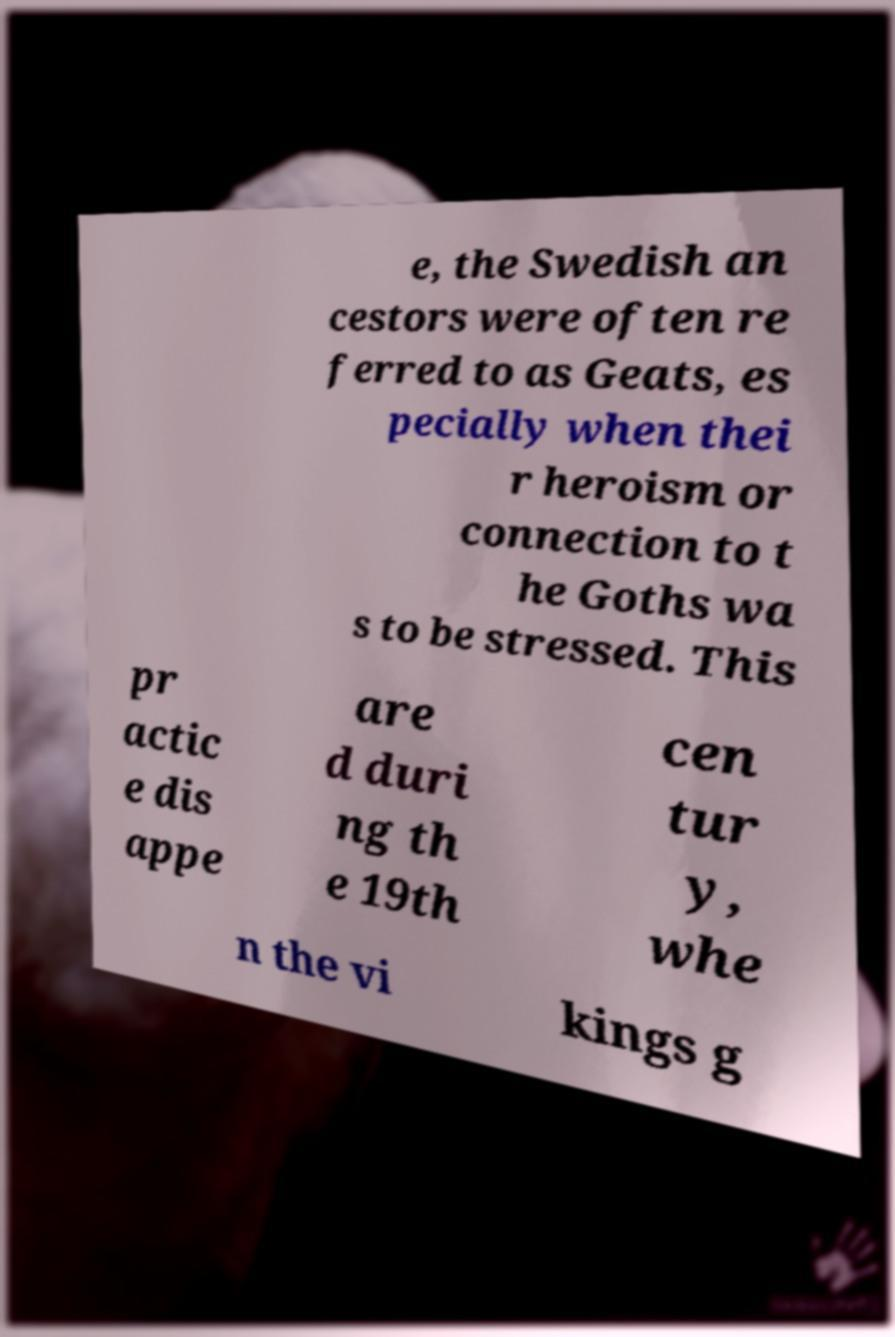I need the written content from this picture converted into text. Can you do that? e, the Swedish an cestors were often re ferred to as Geats, es pecially when thei r heroism or connection to t he Goths wa s to be stressed. This pr actic e dis appe are d duri ng th e 19th cen tur y, whe n the vi kings g 